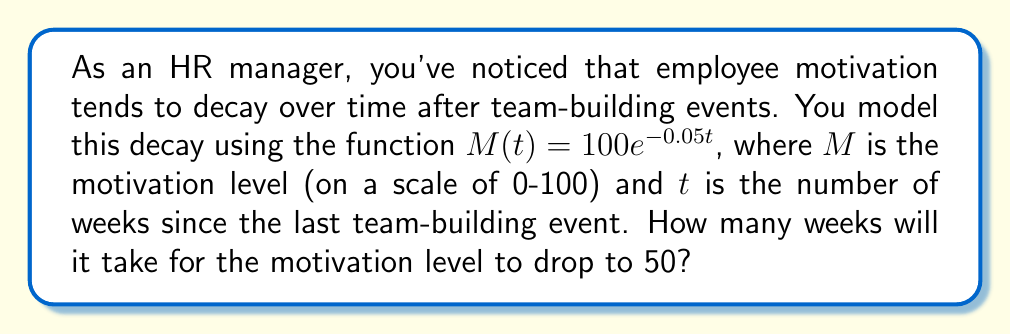Solve this math problem. Let's approach this step-by-step:

1) We start with the equation $M(t) = 100e^{-0.05t}$

2) We want to find $t$ when $M(t) = 50$. So, let's set up the equation:

   $50 = 100e^{-0.05t}$

3) Divide both sides by 100:

   $\frac{1}{2} = e^{-0.05t}$

4) Now, we need to solve for $t$. We can do this by taking the natural logarithm of both sides:

   $\ln(\frac{1}{2}) = \ln(e^{-0.05t})$

5) The right side simplifies due to the properties of logarithms:

   $\ln(\frac{1}{2}) = -0.05t$

6) Now solve for $t$:

   $t = -\frac{\ln(\frac{1}{2})}{0.05}$

7) $\ln(\frac{1}{2})$ is approximately -0.693

8) So, we have:

   $t = -\frac{-0.693}{0.05} \approx 13.86$

9) Since we're dealing with weeks, we round up to the nearest whole number.
Answer: 14 weeks 